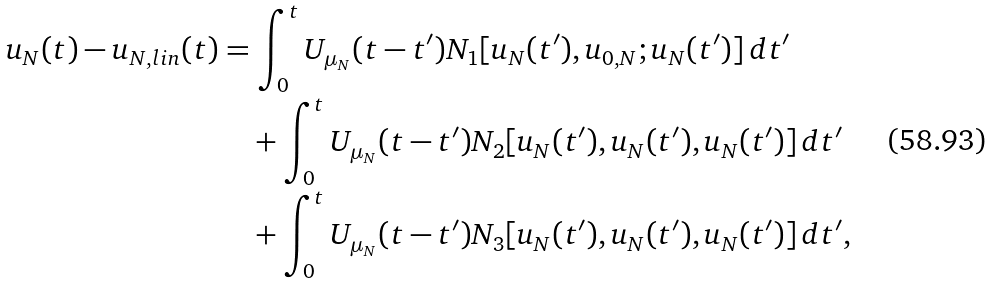Convert formula to latex. <formula><loc_0><loc_0><loc_500><loc_500>u _ { N } ( t ) - u _ { N , l i n } ( t ) & = \int _ { 0 } ^ { t } U _ { \mu _ { N } } ( t - t ^ { \prime } ) N _ { 1 } [ u _ { N } ( t ^ { \prime } ) , u _ { 0 , N } ; u _ { N } ( t ^ { \prime } ) ] \, d t ^ { \prime } \\ & \quad + \int _ { 0 } ^ { t } U _ { \mu _ { N } } ( t - t ^ { \prime } ) N _ { 2 } [ u _ { N } ( t ^ { \prime } ) , u _ { N } ( t ^ { \prime } ) , u _ { N } ( t ^ { \prime } ) ] \, d t ^ { \prime } \\ & \quad + \int _ { 0 } ^ { t } U _ { \mu _ { N } } ( t - t ^ { \prime } ) N _ { 3 } [ u _ { N } ( t ^ { \prime } ) , u _ { N } ( t ^ { \prime } ) , u _ { N } ( t ^ { \prime } ) ] \, d t ^ { \prime } ,</formula> 